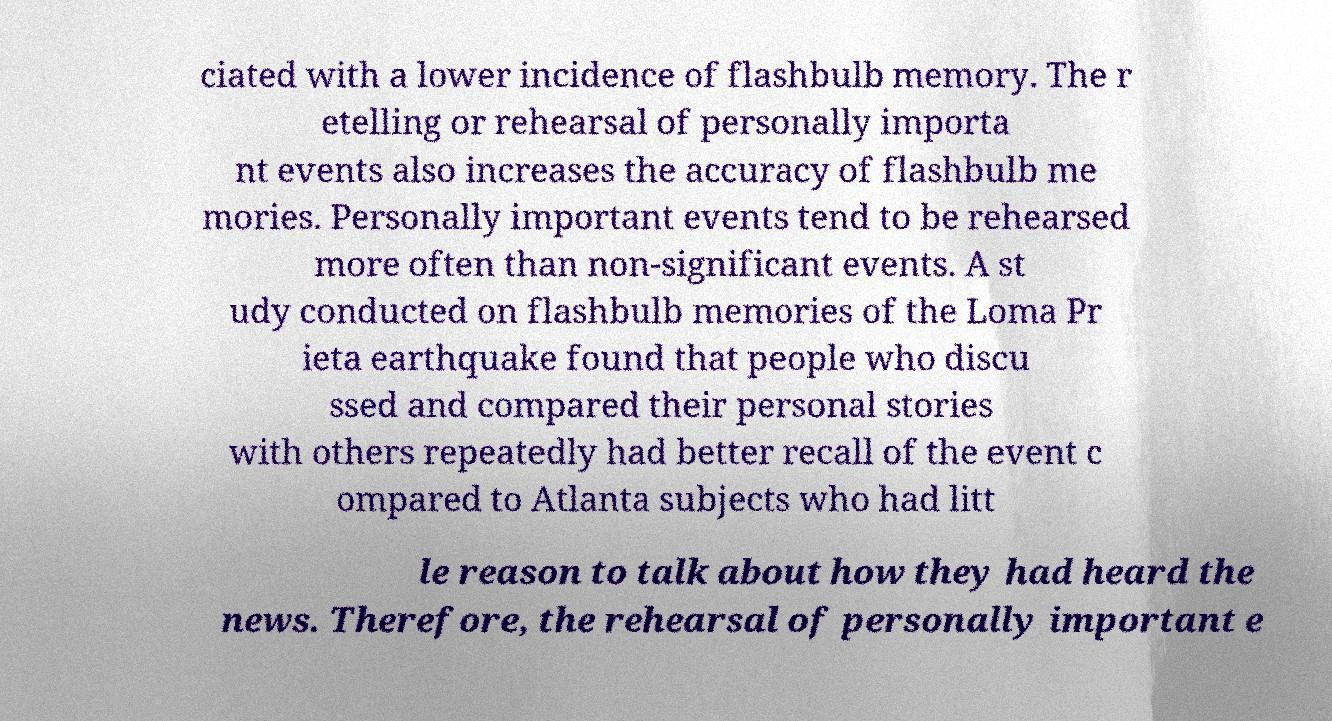Please identify and transcribe the text found in this image. ciated with a lower incidence of flashbulb memory. The r etelling or rehearsal of personally importa nt events also increases the accuracy of flashbulb me mories. Personally important events tend to be rehearsed more often than non-significant events. A st udy conducted on flashbulb memories of the Loma Pr ieta earthquake found that people who discu ssed and compared their personal stories with others repeatedly had better recall of the event c ompared to Atlanta subjects who had litt le reason to talk about how they had heard the news. Therefore, the rehearsal of personally important e 